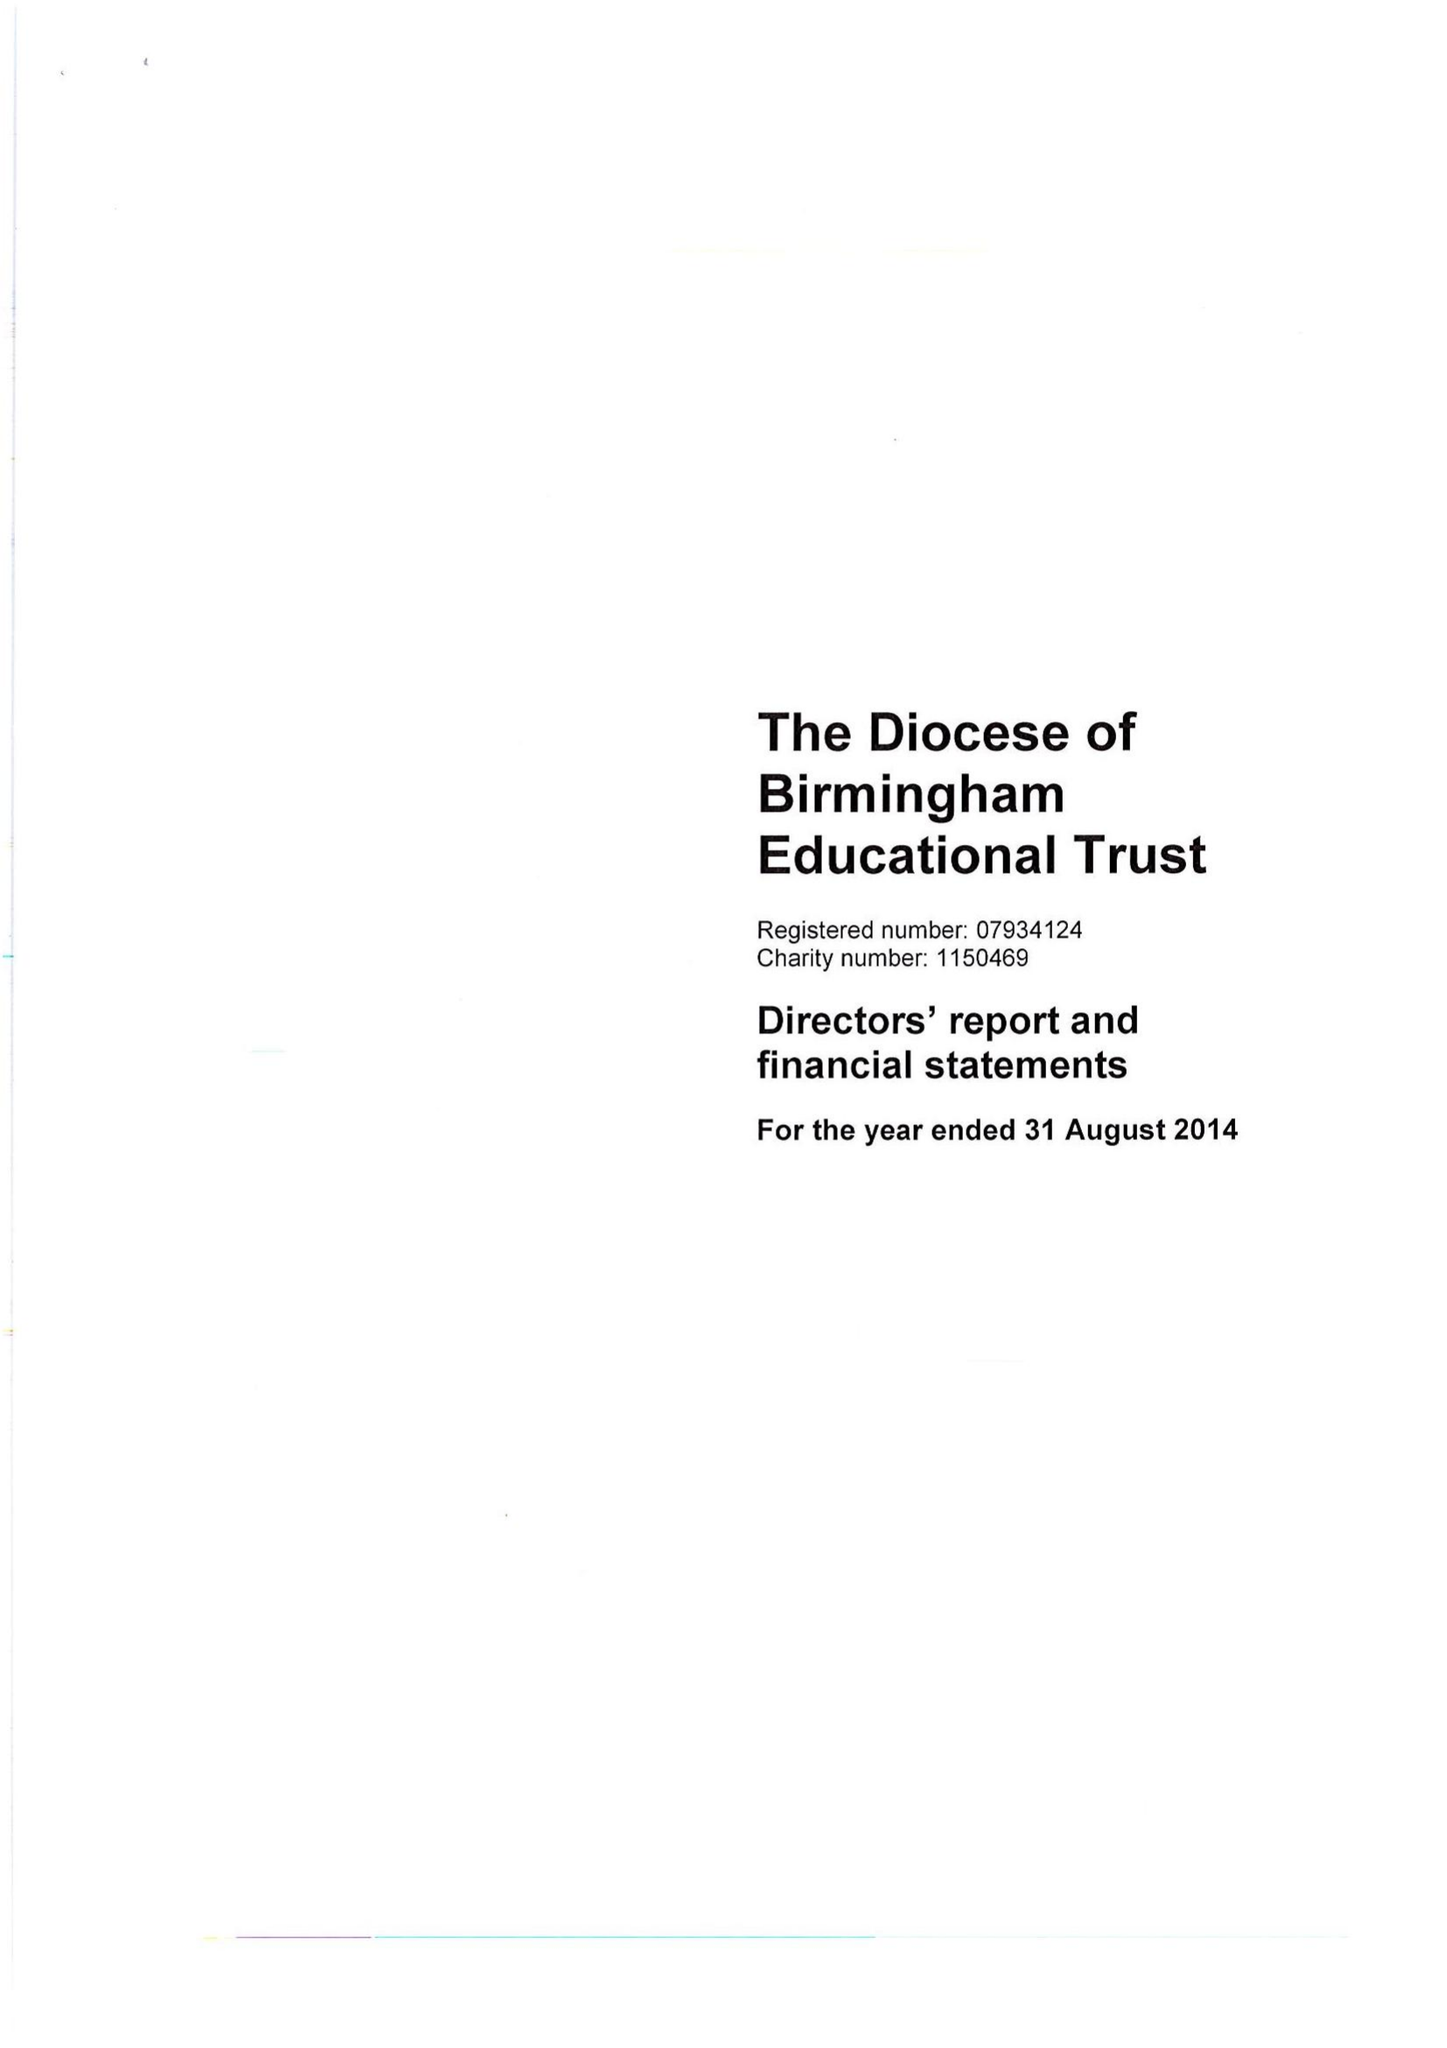What is the value for the charity_number?
Answer the question using a single word or phrase. 1150469 